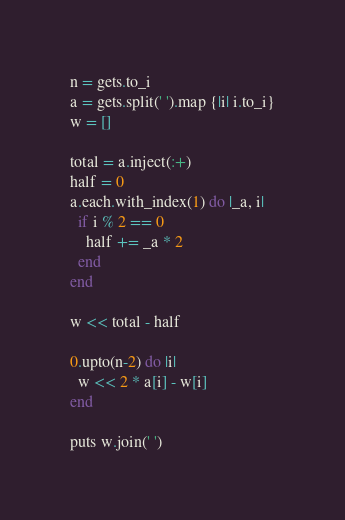<code> <loc_0><loc_0><loc_500><loc_500><_Ruby_>n = gets.to_i
a = gets.split(' ').map {|i| i.to_i}
w = []

total = a.inject(:+)
half = 0
a.each.with_index(1) do |_a, i|
  if i % 2 == 0
    half += _a * 2
  end
end

w << total - half

0.upto(n-2) do |i|
  w << 2 * a[i] - w[i]
end

puts w.join(' ')</code> 